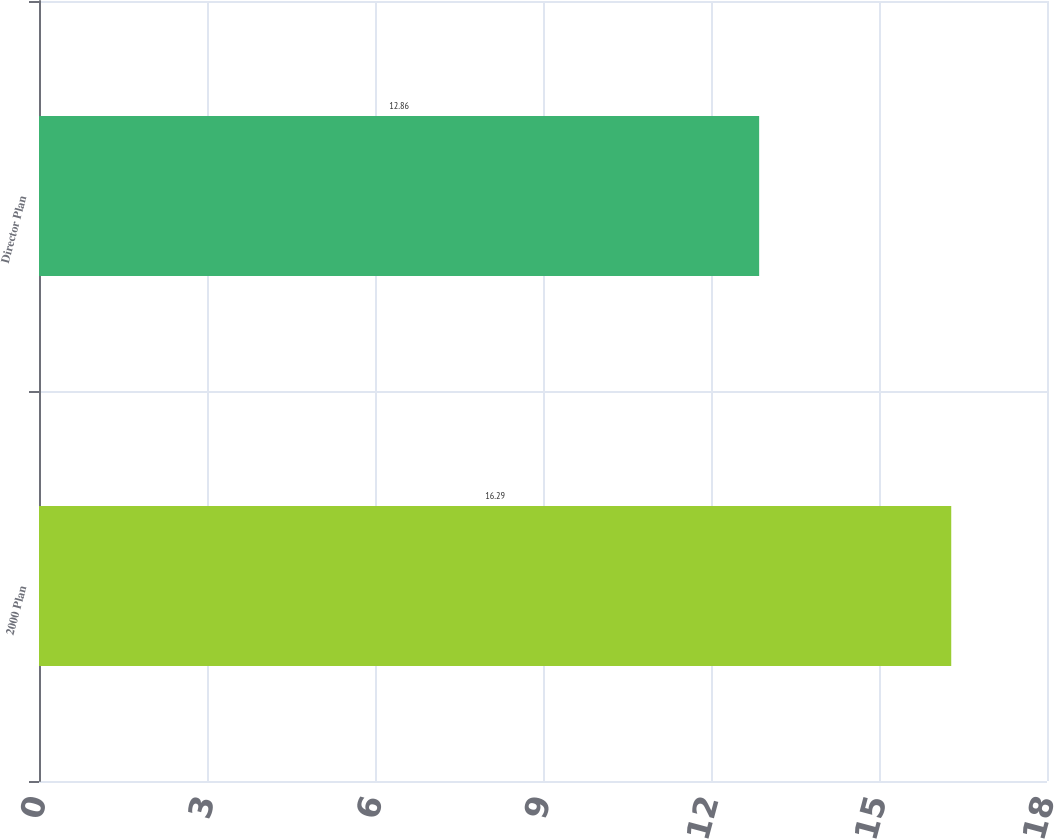Convert chart to OTSL. <chart><loc_0><loc_0><loc_500><loc_500><bar_chart><fcel>2000 Plan<fcel>Director Plan<nl><fcel>16.29<fcel>12.86<nl></chart> 